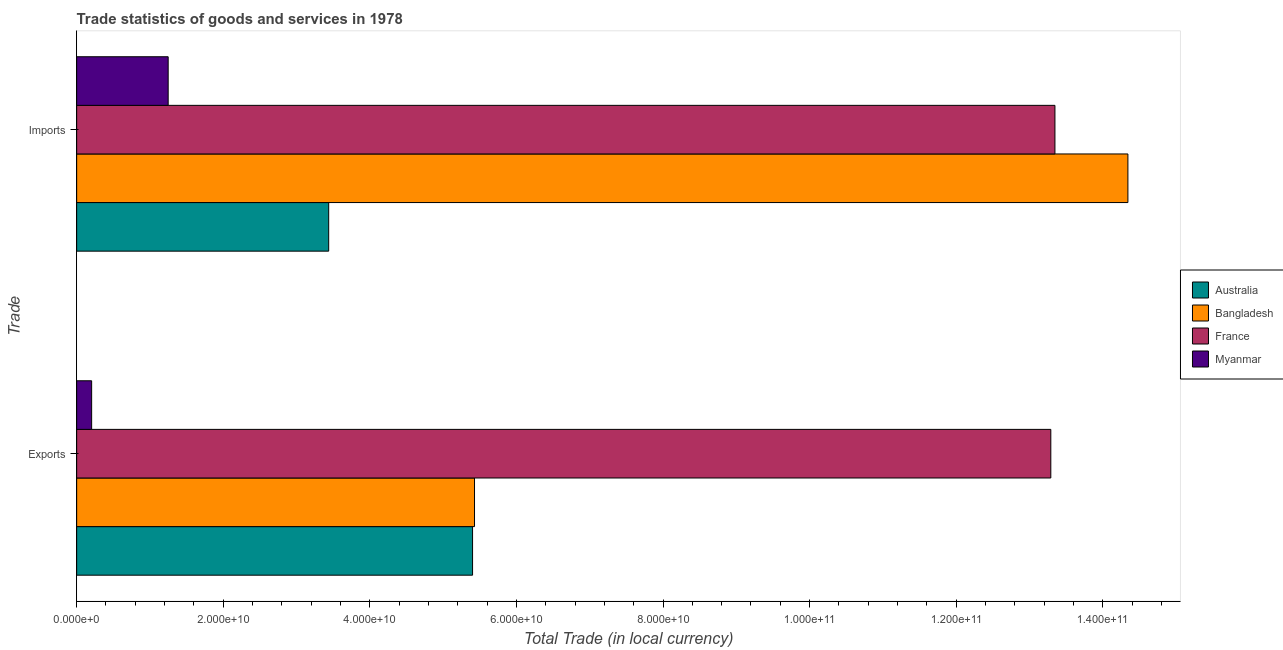How many different coloured bars are there?
Give a very brief answer. 4. Are the number of bars per tick equal to the number of legend labels?
Offer a terse response. Yes. What is the label of the 1st group of bars from the top?
Your answer should be very brief. Imports. What is the imports of goods and services in Australia?
Your answer should be very brief. 3.44e+1. Across all countries, what is the maximum imports of goods and services?
Your answer should be compact. 1.43e+11. Across all countries, what is the minimum export of goods and services?
Keep it short and to the point. 2.04e+09. In which country was the export of goods and services minimum?
Keep it short and to the point. Myanmar. What is the total imports of goods and services in the graph?
Offer a terse response. 3.24e+11. What is the difference between the imports of goods and services in Australia and that in Bangladesh?
Your response must be concise. -1.09e+11. What is the difference between the imports of goods and services in Bangladesh and the export of goods and services in France?
Ensure brevity in your answer.  1.05e+1. What is the average imports of goods and services per country?
Offer a terse response. 8.09e+1. What is the difference between the imports of goods and services and export of goods and services in Australia?
Offer a terse response. -1.96e+1. In how many countries, is the imports of goods and services greater than 16000000000 LCU?
Your answer should be very brief. 3. What is the ratio of the export of goods and services in France to that in Australia?
Your answer should be very brief. 2.46. Is the export of goods and services in Bangladesh less than that in Myanmar?
Provide a succinct answer. No. Are all the bars in the graph horizontal?
Your response must be concise. Yes. What is the difference between two consecutive major ticks on the X-axis?
Your answer should be compact. 2.00e+1. Does the graph contain any zero values?
Provide a short and direct response. No. Does the graph contain grids?
Keep it short and to the point. No. How are the legend labels stacked?
Offer a very short reply. Vertical. What is the title of the graph?
Ensure brevity in your answer.  Trade statistics of goods and services in 1978. What is the label or title of the X-axis?
Provide a succinct answer. Total Trade (in local currency). What is the label or title of the Y-axis?
Offer a very short reply. Trade. What is the Total Trade (in local currency) of Australia in Exports?
Keep it short and to the point. 5.40e+1. What is the Total Trade (in local currency) of Bangladesh in Exports?
Your response must be concise. 5.43e+1. What is the Total Trade (in local currency) of France in Exports?
Give a very brief answer. 1.33e+11. What is the Total Trade (in local currency) in Myanmar in Exports?
Offer a very short reply. 2.04e+09. What is the Total Trade (in local currency) in Australia in Imports?
Offer a very short reply. 3.44e+1. What is the Total Trade (in local currency) in Bangladesh in Imports?
Offer a very short reply. 1.43e+11. What is the Total Trade (in local currency) in France in Imports?
Keep it short and to the point. 1.33e+11. What is the Total Trade (in local currency) of Myanmar in Imports?
Ensure brevity in your answer.  1.25e+1. Across all Trade, what is the maximum Total Trade (in local currency) in Australia?
Keep it short and to the point. 5.40e+1. Across all Trade, what is the maximum Total Trade (in local currency) in Bangladesh?
Offer a very short reply. 1.43e+11. Across all Trade, what is the maximum Total Trade (in local currency) in France?
Your response must be concise. 1.33e+11. Across all Trade, what is the maximum Total Trade (in local currency) in Myanmar?
Your response must be concise. 1.25e+1. Across all Trade, what is the minimum Total Trade (in local currency) in Australia?
Your answer should be compact. 3.44e+1. Across all Trade, what is the minimum Total Trade (in local currency) in Bangladesh?
Provide a short and direct response. 5.43e+1. Across all Trade, what is the minimum Total Trade (in local currency) of France?
Provide a succinct answer. 1.33e+11. Across all Trade, what is the minimum Total Trade (in local currency) in Myanmar?
Ensure brevity in your answer.  2.04e+09. What is the total Total Trade (in local currency) in Australia in the graph?
Ensure brevity in your answer.  8.84e+1. What is the total Total Trade (in local currency) of Bangladesh in the graph?
Your response must be concise. 1.98e+11. What is the total Total Trade (in local currency) of France in the graph?
Make the answer very short. 2.66e+11. What is the total Total Trade (in local currency) in Myanmar in the graph?
Offer a very short reply. 1.45e+1. What is the difference between the Total Trade (in local currency) of Australia in Exports and that in Imports?
Provide a succinct answer. 1.96e+1. What is the difference between the Total Trade (in local currency) in Bangladesh in Exports and that in Imports?
Make the answer very short. -8.91e+1. What is the difference between the Total Trade (in local currency) in France in Exports and that in Imports?
Offer a terse response. -5.63e+08. What is the difference between the Total Trade (in local currency) in Myanmar in Exports and that in Imports?
Offer a very short reply. -1.04e+1. What is the difference between the Total Trade (in local currency) of Australia in Exports and the Total Trade (in local currency) of Bangladesh in Imports?
Offer a terse response. -8.94e+1. What is the difference between the Total Trade (in local currency) of Australia in Exports and the Total Trade (in local currency) of France in Imports?
Keep it short and to the point. -7.95e+1. What is the difference between the Total Trade (in local currency) of Australia in Exports and the Total Trade (in local currency) of Myanmar in Imports?
Offer a very short reply. 4.15e+1. What is the difference between the Total Trade (in local currency) in Bangladesh in Exports and the Total Trade (in local currency) in France in Imports?
Make the answer very short. -7.92e+1. What is the difference between the Total Trade (in local currency) of Bangladesh in Exports and the Total Trade (in local currency) of Myanmar in Imports?
Make the answer very short. 4.18e+1. What is the difference between the Total Trade (in local currency) in France in Exports and the Total Trade (in local currency) in Myanmar in Imports?
Give a very brief answer. 1.20e+11. What is the average Total Trade (in local currency) in Australia per Trade?
Provide a short and direct response. 4.42e+1. What is the average Total Trade (in local currency) in Bangladesh per Trade?
Your answer should be very brief. 9.89e+1. What is the average Total Trade (in local currency) of France per Trade?
Your answer should be very brief. 1.33e+11. What is the average Total Trade (in local currency) of Myanmar per Trade?
Offer a very short reply. 7.26e+09. What is the difference between the Total Trade (in local currency) of Australia and Total Trade (in local currency) of Bangladesh in Exports?
Your response must be concise. -2.68e+08. What is the difference between the Total Trade (in local currency) in Australia and Total Trade (in local currency) in France in Exports?
Offer a terse response. -7.89e+1. What is the difference between the Total Trade (in local currency) of Australia and Total Trade (in local currency) of Myanmar in Exports?
Your answer should be very brief. 5.20e+1. What is the difference between the Total Trade (in local currency) in Bangladesh and Total Trade (in local currency) in France in Exports?
Your answer should be compact. -7.86e+1. What is the difference between the Total Trade (in local currency) in Bangladesh and Total Trade (in local currency) in Myanmar in Exports?
Offer a very short reply. 5.22e+1. What is the difference between the Total Trade (in local currency) of France and Total Trade (in local currency) of Myanmar in Exports?
Keep it short and to the point. 1.31e+11. What is the difference between the Total Trade (in local currency) in Australia and Total Trade (in local currency) in Bangladesh in Imports?
Ensure brevity in your answer.  -1.09e+11. What is the difference between the Total Trade (in local currency) of Australia and Total Trade (in local currency) of France in Imports?
Provide a short and direct response. -9.91e+1. What is the difference between the Total Trade (in local currency) in Australia and Total Trade (in local currency) in Myanmar in Imports?
Provide a short and direct response. 2.19e+1. What is the difference between the Total Trade (in local currency) of Bangladesh and Total Trade (in local currency) of France in Imports?
Keep it short and to the point. 9.95e+09. What is the difference between the Total Trade (in local currency) in Bangladesh and Total Trade (in local currency) in Myanmar in Imports?
Ensure brevity in your answer.  1.31e+11. What is the difference between the Total Trade (in local currency) in France and Total Trade (in local currency) in Myanmar in Imports?
Provide a short and direct response. 1.21e+11. What is the ratio of the Total Trade (in local currency) in Australia in Exports to that in Imports?
Your answer should be compact. 1.57. What is the ratio of the Total Trade (in local currency) of Bangladesh in Exports to that in Imports?
Your answer should be very brief. 0.38. What is the ratio of the Total Trade (in local currency) in Myanmar in Exports to that in Imports?
Make the answer very short. 0.16. What is the difference between the highest and the second highest Total Trade (in local currency) in Australia?
Provide a short and direct response. 1.96e+1. What is the difference between the highest and the second highest Total Trade (in local currency) of Bangladesh?
Provide a short and direct response. 8.91e+1. What is the difference between the highest and the second highest Total Trade (in local currency) in France?
Offer a very short reply. 5.63e+08. What is the difference between the highest and the second highest Total Trade (in local currency) of Myanmar?
Offer a very short reply. 1.04e+1. What is the difference between the highest and the lowest Total Trade (in local currency) of Australia?
Give a very brief answer. 1.96e+1. What is the difference between the highest and the lowest Total Trade (in local currency) in Bangladesh?
Ensure brevity in your answer.  8.91e+1. What is the difference between the highest and the lowest Total Trade (in local currency) in France?
Your answer should be very brief. 5.63e+08. What is the difference between the highest and the lowest Total Trade (in local currency) in Myanmar?
Give a very brief answer. 1.04e+1. 